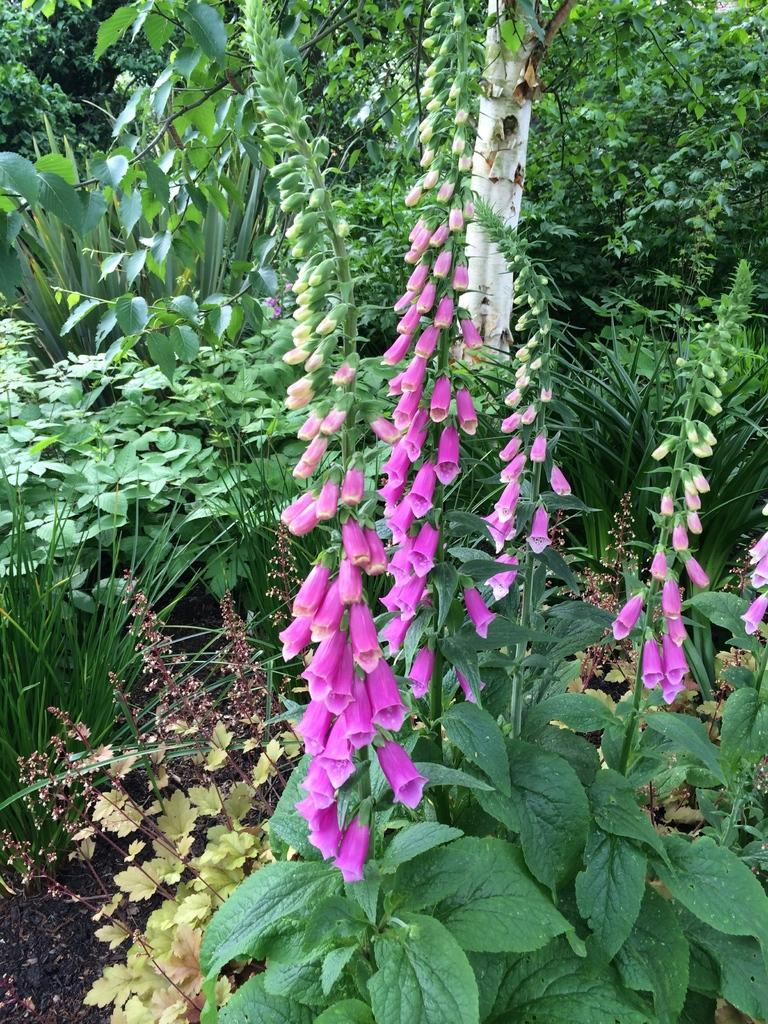What type of vegetation is present in the image? There are trees in the image. What additional features can be observed on the trees? The trees have flowers and leaves. How many clocks can be seen hanging from the branches of the trees in the image? There are no clocks present in the image; it features trees with flowers and leaves. What type of ice is visible on the leaves of the trees in the image? There is no ice present on the leaves of the trees in the image. 